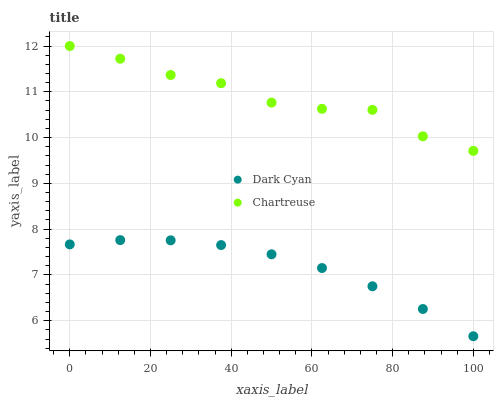Does Dark Cyan have the minimum area under the curve?
Answer yes or no. Yes. Does Chartreuse have the maximum area under the curve?
Answer yes or no. Yes. Does Chartreuse have the minimum area under the curve?
Answer yes or no. No. Is Dark Cyan the smoothest?
Answer yes or no. Yes. Is Chartreuse the roughest?
Answer yes or no. Yes. Is Chartreuse the smoothest?
Answer yes or no. No. Does Dark Cyan have the lowest value?
Answer yes or no. Yes. Does Chartreuse have the lowest value?
Answer yes or no. No. Does Chartreuse have the highest value?
Answer yes or no. Yes. Is Dark Cyan less than Chartreuse?
Answer yes or no. Yes. Is Chartreuse greater than Dark Cyan?
Answer yes or no. Yes. Does Dark Cyan intersect Chartreuse?
Answer yes or no. No. 